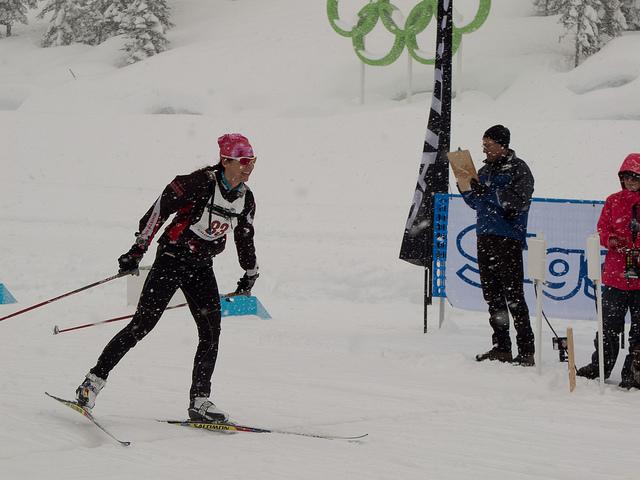What are they doing?
Be succinct. Skiing. What color is the flag?
Be succinct. Black. Is this man skiing in a face?
Keep it brief. No. What number is written on his shirt?
Give a very brief answer. 83. Are they learning how to snowboard?
Quick response, please. No. How many people are in the scene?
Write a very short answer. 3. Does the child have a hat on?
Keep it brief. Yes. Which skier has the flashiest pants?
Short answer required. None. How many skiers are there?
Quick response, please. 1. What color is the Olympic logo?
Write a very short answer. Green. How many men are in the picture?
Give a very brief answer. 2. 